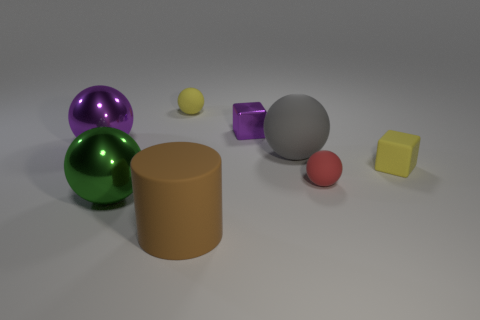Can you infer the lighting in this scene based on the shadows and highlights? Yes, the scene is likely lit by a single light source located towards the top right from the perspective of the observer. This can be inferred from the direction of the shadows primarily being cast to the lower left of the objects, as well as the highlights visible on the upper right sides of the objects. What can you tell about the texture of the surface the objects are on? The surface appears smooth and even, with no noticeable texture or pattern. It has a matte finish, which allows the shadows to be softly diffused and doesn't produce any significant reflection of the objects. 